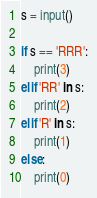Convert code to text. <code><loc_0><loc_0><loc_500><loc_500><_Python_>s = input()

if s == 'RRR':
    print(3)
elif 'RR' in s:
    print(2)
elif 'R' in s:
    print(1)
else:
    print(0)
</code> 